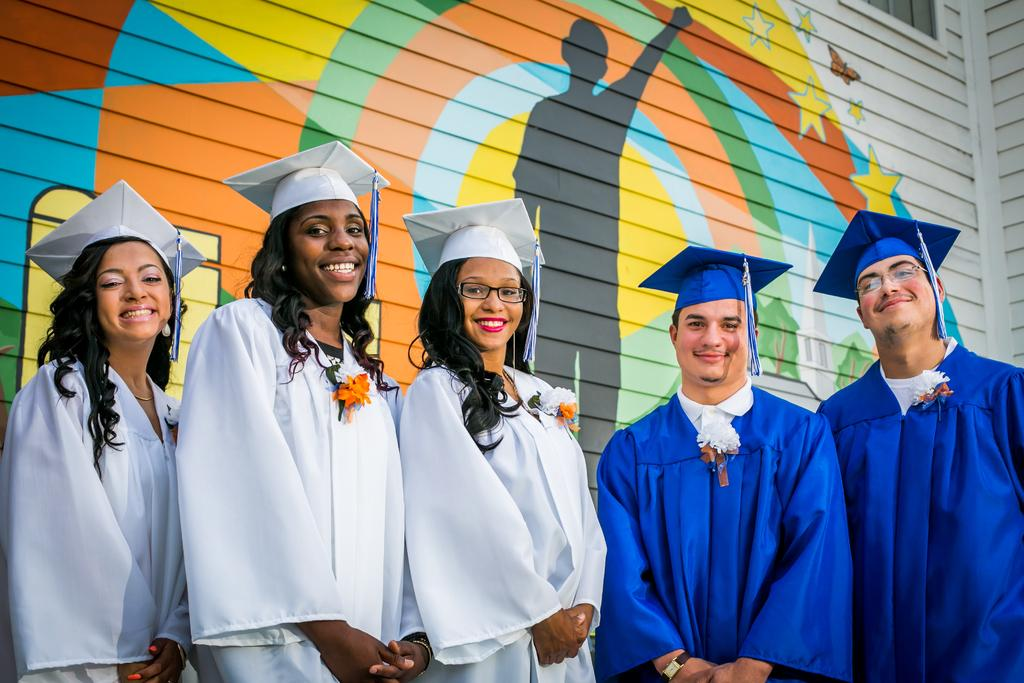What are the people in the image wearing? The people in the image are wearing graduation suits. What type of headwear can be seen on the people? The people are wearing hats. What can be seen on the wall in the image? There is some art on the wall in the image. What color of paint is being used on the gold lock in the image? There is no paint, gold, or lock present in the image. 